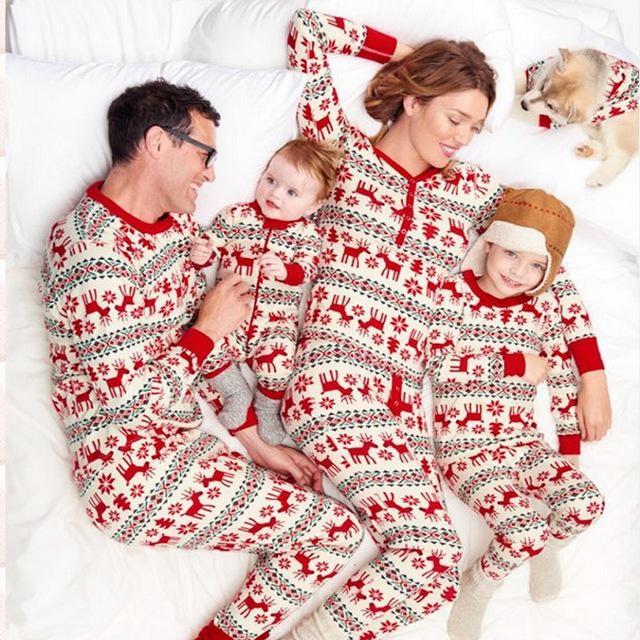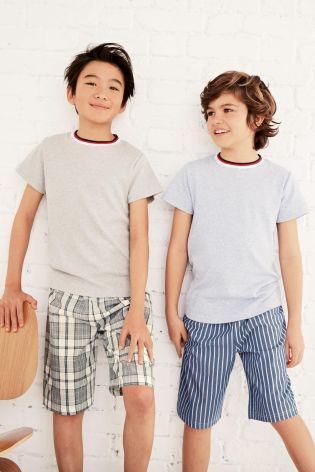The first image is the image on the left, the second image is the image on the right. Analyze the images presented: Is the assertion "There are four people in each set of images." valid? Answer yes or no. No. 